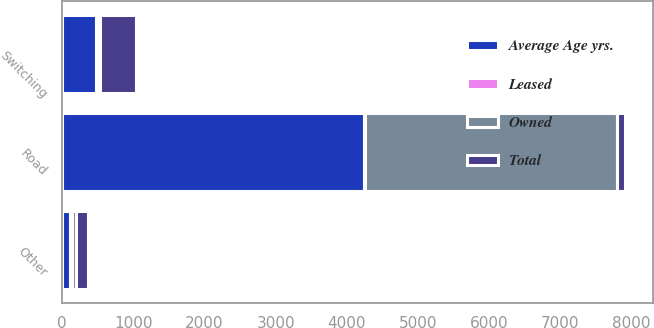Convert chart to OTSL. <chart><loc_0><loc_0><loc_500><loc_500><stacked_bar_chart><ecel><fcel>Road<fcel>Switching<fcel>Other<nl><fcel>Average Age yrs.<fcel>4247<fcel>475<fcel>112<nl><fcel>Owned<fcel>3531<fcel>28<fcel>55<nl><fcel>Total<fcel>112<fcel>503<fcel>167<nl><fcel>Leased<fcel>14.6<fcel>30.6<fcel>21.5<nl></chart> 